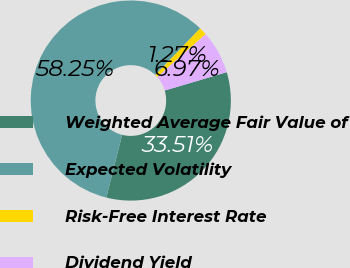Convert chart to OTSL. <chart><loc_0><loc_0><loc_500><loc_500><pie_chart><fcel>Weighted Average Fair Value of<fcel>Expected Volatility<fcel>Risk-Free Interest Rate<fcel>Dividend Yield<nl><fcel>33.51%<fcel>58.25%<fcel>1.27%<fcel>6.97%<nl></chart> 